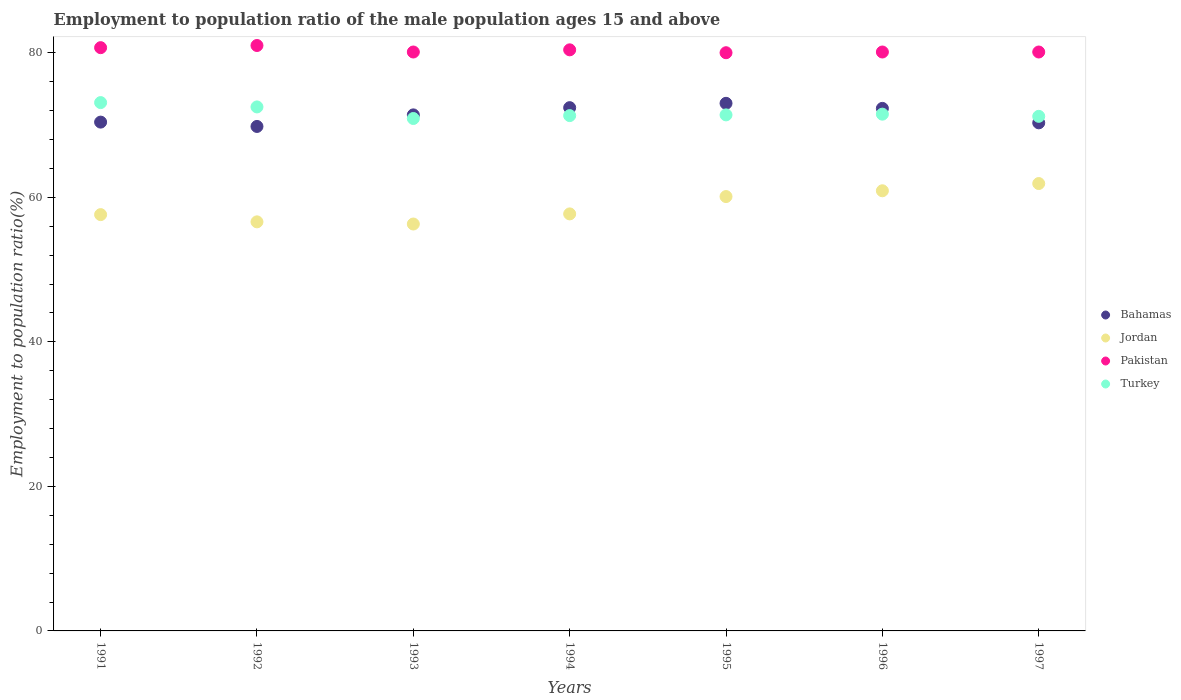What is the employment to population ratio in Bahamas in 1997?
Provide a succinct answer. 70.3. Across all years, what is the maximum employment to population ratio in Jordan?
Offer a terse response. 61.9. Across all years, what is the minimum employment to population ratio in Turkey?
Give a very brief answer. 70.9. In which year was the employment to population ratio in Pakistan maximum?
Keep it short and to the point. 1992. In which year was the employment to population ratio in Pakistan minimum?
Make the answer very short. 1995. What is the total employment to population ratio in Bahamas in the graph?
Offer a terse response. 499.6. What is the difference between the employment to population ratio in Pakistan in 1991 and the employment to population ratio in Turkey in 1995?
Provide a short and direct response. 9.3. What is the average employment to population ratio in Turkey per year?
Make the answer very short. 71.7. In the year 1992, what is the difference between the employment to population ratio in Pakistan and employment to population ratio in Bahamas?
Provide a succinct answer. 11.2. In how many years, is the employment to population ratio in Bahamas greater than 48 %?
Keep it short and to the point. 7. What is the ratio of the employment to population ratio in Pakistan in 1995 to that in 1997?
Your answer should be compact. 1. Is the employment to population ratio in Pakistan in 1993 less than that in 1996?
Offer a terse response. No. Is the difference between the employment to population ratio in Pakistan in 1995 and 1997 greater than the difference between the employment to population ratio in Bahamas in 1995 and 1997?
Your response must be concise. No. What is the difference between the highest and the second highest employment to population ratio in Bahamas?
Ensure brevity in your answer.  0.6. What is the difference between the highest and the lowest employment to population ratio in Jordan?
Make the answer very short. 5.6. Is it the case that in every year, the sum of the employment to population ratio in Jordan and employment to population ratio in Bahamas  is greater than the sum of employment to population ratio in Turkey and employment to population ratio in Pakistan?
Offer a terse response. No. Is it the case that in every year, the sum of the employment to population ratio in Turkey and employment to population ratio in Jordan  is greater than the employment to population ratio in Pakistan?
Your response must be concise. Yes. Is the employment to population ratio in Pakistan strictly less than the employment to population ratio in Bahamas over the years?
Make the answer very short. No. How many years are there in the graph?
Give a very brief answer. 7. Are the values on the major ticks of Y-axis written in scientific E-notation?
Your response must be concise. No. Does the graph contain grids?
Your answer should be compact. No. Where does the legend appear in the graph?
Offer a very short reply. Center right. How many legend labels are there?
Your response must be concise. 4. How are the legend labels stacked?
Ensure brevity in your answer.  Vertical. What is the title of the graph?
Offer a terse response. Employment to population ratio of the male population ages 15 and above. Does "Argentina" appear as one of the legend labels in the graph?
Your answer should be very brief. No. What is the label or title of the X-axis?
Provide a short and direct response. Years. What is the Employment to population ratio(%) of Bahamas in 1991?
Provide a succinct answer. 70.4. What is the Employment to population ratio(%) in Jordan in 1991?
Provide a short and direct response. 57.6. What is the Employment to population ratio(%) in Pakistan in 1991?
Keep it short and to the point. 80.7. What is the Employment to population ratio(%) of Turkey in 1991?
Provide a short and direct response. 73.1. What is the Employment to population ratio(%) of Bahamas in 1992?
Offer a terse response. 69.8. What is the Employment to population ratio(%) in Jordan in 1992?
Ensure brevity in your answer.  56.6. What is the Employment to population ratio(%) of Turkey in 1992?
Provide a succinct answer. 72.5. What is the Employment to population ratio(%) in Bahamas in 1993?
Keep it short and to the point. 71.4. What is the Employment to population ratio(%) of Jordan in 1993?
Your answer should be very brief. 56.3. What is the Employment to population ratio(%) in Pakistan in 1993?
Ensure brevity in your answer.  80.1. What is the Employment to population ratio(%) of Turkey in 1993?
Your answer should be compact. 70.9. What is the Employment to population ratio(%) in Bahamas in 1994?
Your response must be concise. 72.4. What is the Employment to population ratio(%) of Jordan in 1994?
Your answer should be compact. 57.7. What is the Employment to population ratio(%) of Pakistan in 1994?
Offer a very short reply. 80.4. What is the Employment to population ratio(%) of Turkey in 1994?
Offer a terse response. 71.3. What is the Employment to population ratio(%) in Jordan in 1995?
Keep it short and to the point. 60.1. What is the Employment to population ratio(%) of Turkey in 1995?
Offer a very short reply. 71.4. What is the Employment to population ratio(%) of Bahamas in 1996?
Keep it short and to the point. 72.3. What is the Employment to population ratio(%) in Jordan in 1996?
Offer a terse response. 60.9. What is the Employment to population ratio(%) in Pakistan in 1996?
Your response must be concise. 80.1. What is the Employment to population ratio(%) of Turkey in 1996?
Your answer should be very brief. 71.5. What is the Employment to population ratio(%) in Bahamas in 1997?
Offer a terse response. 70.3. What is the Employment to population ratio(%) of Jordan in 1997?
Make the answer very short. 61.9. What is the Employment to population ratio(%) of Pakistan in 1997?
Keep it short and to the point. 80.1. What is the Employment to population ratio(%) in Turkey in 1997?
Keep it short and to the point. 71.2. Across all years, what is the maximum Employment to population ratio(%) of Bahamas?
Offer a very short reply. 73. Across all years, what is the maximum Employment to population ratio(%) in Jordan?
Your answer should be compact. 61.9. Across all years, what is the maximum Employment to population ratio(%) of Pakistan?
Provide a short and direct response. 81. Across all years, what is the maximum Employment to population ratio(%) of Turkey?
Ensure brevity in your answer.  73.1. Across all years, what is the minimum Employment to population ratio(%) in Bahamas?
Ensure brevity in your answer.  69.8. Across all years, what is the minimum Employment to population ratio(%) of Jordan?
Ensure brevity in your answer.  56.3. Across all years, what is the minimum Employment to population ratio(%) of Pakistan?
Your answer should be very brief. 80. Across all years, what is the minimum Employment to population ratio(%) in Turkey?
Your answer should be very brief. 70.9. What is the total Employment to population ratio(%) of Bahamas in the graph?
Make the answer very short. 499.6. What is the total Employment to population ratio(%) of Jordan in the graph?
Provide a short and direct response. 411.1. What is the total Employment to population ratio(%) in Pakistan in the graph?
Offer a terse response. 562.4. What is the total Employment to population ratio(%) of Turkey in the graph?
Offer a very short reply. 501.9. What is the difference between the Employment to population ratio(%) in Bahamas in 1991 and that in 1992?
Make the answer very short. 0.6. What is the difference between the Employment to population ratio(%) of Turkey in 1991 and that in 1992?
Your answer should be compact. 0.6. What is the difference between the Employment to population ratio(%) of Bahamas in 1991 and that in 1993?
Ensure brevity in your answer.  -1. What is the difference between the Employment to population ratio(%) in Pakistan in 1991 and that in 1993?
Give a very brief answer. 0.6. What is the difference between the Employment to population ratio(%) in Bahamas in 1991 and that in 1994?
Provide a succinct answer. -2. What is the difference between the Employment to population ratio(%) in Pakistan in 1991 and that in 1994?
Make the answer very short. 0.3. What is the difference between the Employment to population ratio(%) in Turkey in 1991 and that in 1994?
Your answer should be very brief. 1.8. What is the difference between the Employment to population ratio(%) in Turkey in 1991 and that in 1995?
Ensure brevity in your answer.  1.7. What is the difference between the Employment to population ratio(%) in Jordan in 1991 and that in 1996?
Provide a succinct answer. -3.3. What is the difference between the Employment to population ratio(%) of Pakistan in 1991 and that in 1996?
Your answer should be very brief. 0.6. What is the difference between the Employment to population ratio(%) in Bahamas in 1991 and that in 1997?
Your answer should be very brief. 0.1. What is the difference between the Employment to population ratio(%) in Pakistan in 1991 and that in 1997?
Provide a succinct answer. 0.6. What is the difference between the Employment to population ratio(%) in Pakistan in 1992 and that in 1993?
Make the answer very short. 0.9. What is the difference between the Employment to population ratio(%) of Turkey in 1992 and that in 1994?
Keep it short and to the point. 1.2. What is the difference between the Employment to population ratio(%) of Bahamas in 1992 and that in 1995?
Make the answer very short. -3.2. What is the difference between the Employment to population ratio(%) in Pakistan in 1992 and that in 1995?
Ensure brevity in your answer.  1. What is the difference between the Employment to population ratio(%) of Turkey in 1992 and that in 1995?
Ensure brevity in your answer.  1.1. What is the difference between the Employment to population ratio(%) in Jordan in 1992 and that in 1996?
Your answer should be compact. -4.3. What is the difference between the Employment to population ratio(%) in Pakistan in 1992 and that in 1996?
Offer a very short reply. 0.9. What is the difference between the Employment to population ratio(%) of Turkey in 1992 and that in 1996?
Provide a short and direct response. 1. What is the difference between the Employment to population ratio(%) in Jordan in 1992 and that in 1997?
Provide a succinct answer. -5.3. What is the difference between the Employment to population ratio(%) in Pakistan in 1992 and that in 1997?
Make the answer very short. 0.9. What is the difference between the Employment to population ratio(%) in Turkey in 1992 and that in 1997?
Offer a terse response. 1.3. What is the difference between the Employment to population ratio(%) of Bahamas in 1993 and that in 1994?
Your response must be concise. -1. What is the difference between the Employment to population ratio(%) of Jordan in 1993 and that in 1994?
Keep it short and to the point. -1.4. What is the difference between the Employment to population ratio(%) of Bahamas in 1993 and that in 1995?
Provide a short and direct response. -1.6. What is the difference between the Employment to population ratio(%) of Jordan in 1993 and that in 1995?
Ensure brevity in your answer.  -3.8. What is the difference between the Employment to population ratio(%) of Pakistan in 1993 and that in 1995?
Provide a short and direct response. 0.1. What is the difference between the Employment to population ratio(%) in Bahamas in 1993 and that in 1996?
Your response must be concise. -0.9. What is the difference between the Employment to population ratio(%) in Jordan in 1993 and that in 1996?
Offer a very short reply. -4.6. What is the difference between the Employment to population ratio(%) of Turkey in 1993 and that in 1996?
Provide a succinct answer. -0.6. What is the difference between the Employment to population ratio(%) of Bahamas in 1993 and that in 1997?
Your answer should be very brief. 1.1. What is the difference between the Employment to population ratio(%) of Jordan in 1993 and that in 1997?
Offer a terse response. -5.6. What is the difference between the Employment to population ratio(%) of Pakistan in 1993 and that in 1997?
Your response must be concise. 0. What is the difference between the Employment to population ratio(%) in Turkey in 1993 and that in 1997?
Keep it short and to the point. -0.3. What is the difference between the Employment to population ratio(%) in Bahamas in 1994 and that in 1995?
Give a very brief answer. -0.6. What is the difference between the Employment to population ratio(%) in Pakistan in 1994 and that in 1995?
Offer a terse response. 0.4. What is the difference between the Employment to population ratio(%) of Bahamas in 1994 and that in 1996?
Your answer should be very brief. 0.1. What is the difference between the Employment to population ratio(%) of Pakistan in 1994 and that in 1996?
Keep it short and to the point. 0.3. What is the difference between the Employment to population ratio(%) of Bahamas in 1995 and that in 1996?
Provide a succinct answer. 0.7. What is the difference between the Employment to population ratio(%) in Turkey in 1995 and that in 1996?
Your answer should be compact. -0.1. What is the difference between the Employment to population ratio(%) in Jordan in 1995 and that in 1997?
Your response must be concise. -1.8. What is the difference between the Employment to population ratio(%) in Pakistan in 1995 and that in 1997?
Your answer should be compact. -0.1. What is the difference between the Employment to population ratio(%) of Pakistan in 1996 and that in 1997?
Your answer should be very brief. 0. What is the difference between the Employment to population ratio(%) in Turkey in 1996 and that in 1997?
Make the answer very short. 0.3. What is the difference between the Employment to population ratio(%) in Bahamas in 1991 and the Employment to population ratio(%) in Pakistan in 1992?
Keep it short and to the point. -10.6. What is the difference between the Employment to population ratio(%) in Jordan in 1991 and the Employment to population ratio(%) in Pakistan in 1992?
Your answer should be compact. -23.4. What is the difference between the Employment to population ratio(%) in Jordan in 1991 and the Employment to population ratio(%) in Turkey in 1992?
Offer a very short reply. -14.9. What is the difference between the Employment to population ratio(%) of Pakistan in 1991 and the Employment to population ratio(%) of Turkey in 1992?
Offer a very short reply. 8.2. What is the difference between the Employment to population ratio(%) in Bahamas in 1991 and the Employment to population ratio(%) in Jordan in 1993?
Offer a terse response. 14.1. What is the difference between the Employment to population ratio(%) of Bahamas in 1991 and the Employment to population ratio(%) of Pakistan in 1993?
Provide a succinct answer. -9.7. What is the difference between the Employment to population ratio(%) in Bahamas in 1991 and the Employment to population ratio(%) in Turkey in 1993?
Provide a short and direct response. -0.5. What is the difference between the Employment to population ratio(%) of Jordan in 1991 and the Employment to population ratio(%) of Pakistan in 1993?
Provide a short and direct response. -22.5. What is the difference between the Employment to population ratio(%) of Pakistan in 1991 and the Employment to population ratio(%) of Turkey in 1993?
Give a very brief answer. 9.8. What is the difference between the Employment to population ratio(%) in Bahamas in 1991 and the Employment to population ratio(%) in Jordan in 1994?
Ensure brevity in your answer.  12.7. What is the difference between the Employment to population ratio(%) of Jordan in 1991 and the Employment to population ratio(%) of Pakistan in 1994?
Ensure brevity in your answer.  -22.8. What is the difference between the Employment to population ratio(%) in Jordan in 1991 and the Employment to population ratio(%) in Turkey in 1994?
Offer a very short reply. -13.7. What is the difference between the Employment to population ratio(%) of Pakistan in 1991 and the Employment to population ratio(%) of Turkey in 1994?
Provide a short and direct response. 9.4. What is the difference between the Employment to population ratio(%) in Bahamas in 1991 and the Employment to population ratio(%) in Turkey in 1995?
Ensure brevity in your answer.  -1. What is the difference between the Employment to population ratio(%) in Jordan in 1991 and the Employment to population ratio(%) in Pakistan in 1995?
Give a very brief answer. -22.4. What is the difference between the Employment to population ratio(%) in Jordan in 1991 and the Employment to population ratio(%) in Turkey in 1995?
Your answer should be compact. -13.8. What is the difference between the Employment to population ratio(%) of Pakistan in 1991 and the Employment to population ratio(%) of Turkey in 1995?
Your answer should be compact. 9.3. What is the difference between the Employment to population ratio(%) in Bahamas in 1991 and the Employment to population ratio(%) in Jordan in 1996?
Provide a short and direct response. 9.5. What is the difference between the Employment to population ratio(%) of Bahamas in 1991 and the Employment to population ratio(%) of Pakistan in 1996?
Give a very brief answer. -9.7. What is the difference between the Employment to population ratio(%) of Bahamas in 1991 and the Employment to population ratio(%) of Turkey in 1996?
Offer a terse response. -1.1. What is the difference between the Employment to population ratio(%) of Jordan in 1991 and the Employment to population ratio(%) of Pakistan in 1996?
Keep it short and to the point. -22.5. What is the difference between the Employment to population ratio(%) in Jordan in 1991 and the Employment to population ratio(%) in Turkey in 1996?
Give a very brief answer. -13.9. What is the difference between the Employment to population ratio(%) in Pakistan in 1991 and the Employment to population ratio(%) in Turkey in 1996?
Your response must be concise. 9.2. What is the difference between the Employment to population ratio(%) of Bahamas in 1991 and the Employment to population ratio(%) of Pakistan in 1997?
Make the answer very short. -9.7. What is the difference between the Employment to population ratio(%) of Jordan in 1991 and the Employment to population ratio(%) of Pakistan in 1997?
Provide a short and direct response. -22.5. What is the difference between the Employment to population ratio(%) of Pakistan in 1991 and the Employment to population ratio(%) of Turkey in 1997?
Provide a short and direct response. 9.5. What is the difference between the Employment to population ratio(%) of Bahamas in 1992 and the Employment to population ratio(%) of Jordan in 1993?
Give a very brief answer. 13.5. What is the difference between the Employment to population ratio(%) of Bahamas in 1992 and the Employment to population ratio(%) of Turkey in 1993?
Offer a terse response. -1.1. What is the difference between the Employment to population ratio(%) of Jordan in 1992 and the Employment to population ratio(%) of Pakistan in 1993?
Provide a short and direct response. -23.5. What is the difference between the Employment to population ratio(%) in Jordan in 1992 and the Employment to population ratio(%) in Turkey in 1993?
Provide a short and direct response. -14.3. What is the difference between the Employment to population ratio(%) in Bahamas in 1992 and the Employment to population ratio(%) in Jordan in 1994?
Make the answer very short. 12.1. What is the difference between the Employment to population ratio(%) of Bahamas in 1992 and the Employment to population ratio(%) of Pakistan in 1994?
Your answer should be compact. -10.6. What is the difference between the Employment to population ratio(%) of Jordan in 1992 and the Employment to population ratio(%) of Pakistan in 1994?
Ensure brevity in your answer.  -23.8. What is the difference between the Employment to population ratio(%) of Jordan in 1992 and the Employment to population ratio(%) of Turkey in 1994?
Your answer should be very brief. -14.7. What is the difference between the Employment to population ratio(%) in Pakistan in 1992 and the Employment to population ratio(%) in Turkey in 1994?
Offer a terse response. 9.7. What is the difference between the Employment to population ratio(%) of Bahamas in 1992 and the Employment to population ratio(%) of Jordan in 1995?
Your answer should be compact. 9.7. What is the difference between the Employment to population ratio(%) in Bahamas in 1992 and the Employment to population ratio(%) in Turkey in 1995?
Offer a very short reply. -1.6. What is the difference between the Employment to population ratio(%) in Jordan in 1992 and the Employment to population ratio(%) in Pakistan in 1995?
Your answer should be very brief. -23.4. What is the difference between the Employment to population ratio(%) in Jordan in 1992 and the Employment to population ratio(%) in Turkey in 1995?
Offer a terse response. -14.8. What is the difference between the Employment to population ratio(%) in Pakistan in 1992 and the Employment to population ratio(%) in Turkey in 1995?
Give a very brief answer. 9.6. What is the difference between the Employment to population ratio(%) in Bahamas in 1992 and the Employment to population ratio(%) in Jordan in 1996?
Ensure brevity in your answer.  8.9. What is the difference between the Employment to population ratio(%) of Bahamas in 1992 and the Employment to population ratio(%) of Pakistan in 1996?
Your response must be concise. -10.3. What is the difference between the Employment to population ratio(%) of Jordan in 1992 and the Employment to population ratio(%) of Pakistan in 1996?
Ensure brevity in your answer.  -23.5. What is the difference between the Employment to population ratio(%) in Jordan in 1992 and the Employment to population ratio(%) in Turkey in 1996?
Keep it short and to the point. -14.9. What is the difference between the Employment to population ratio(%) of Bahamas in 1992 and the Employment to population ratio(%) of Jordan in 1997?
Ensure brevity in your answer.  7.9. What is the difference between the Employment to population ratio(%) of Bahamas in 1992 and the Employment to population ratio(%) of Pakistan in 1997?
Offer a very short reply. -10.3. What is the difference between the Employment to population ratio(%) of Bahamas in 1992 and the Employment to population ratio(%) of Turkey in 1997?
Provide a succinct answer. -1.4. What is the difference between the Employment to population ratio(%) in Jordan in 1992 and the Employment to population ratio(%) in Pakistan in 1997?
Provide a succinct answer. -23.5. What is the difference between the Employment to population ratio(%) of Jordan in 1992 and the Employment to population ratio(%) of Turkey in 1997?
Ensure brevity in your answer.  -14.6. What is the difference between the Employment to population ratio(%) of Bahamas in 1993 and the Employment to population ratio(%) of Jordan in 1994?
Your answer should be very brief. 13.7. What is the difference between the Employment to population ratio(%) in Bahamas in 1993 and the Employment to population ratio(%) in Turkey in 1994?
Ensure brevity in your answer.  0.1. What is the difference between the Employment to population ratio(%) of Jordan in 1993 and the Employment to population ratio(%) of Pakistan in 1994?
Offer a terse response. -24.1. What is the difference between the Employment to population ratio(%) of Jordan in 1993 and the Employment to population ratio(%) of Turkey in 1994?
Make the answer very short. -15. What is the difference between the Employment to population ratio(%) of Pakistan in 1993 and the Employment to population ratio(%) of Turkey in 1994?
Offer a very short reply. 8.8. What is the difference between the Employment to population ratio(%) in Bahamas in 1993 and the Employment to population ratio(%) in Turkey in 1995?
Ensure brevity in your answer.  0. What is the difference between the Employment to population ratio(%) of Jordan in 1993 and the Employment to population ratio(%) of Pakistan in 1995?
Provide a succinct answer. -23.7. What is the difference between the Employment to population ratio(%) in Jordan in 1993 and the Employment to population ratio(%) in Turkey in 1995?
Offer a terse response. -15.1. What is the difference between the Employment to population ratio(%) in Pakistan in 1993 and the Employment to population ratio(%) in Turkey in 1995?
Your answer should be very brief. 8.7. What is the difference between the Employment to population ratio(%) in Bahamas in 1993 and the Employment to population ratio(%) in Pakistan in 1996?
Provide a succinct answer. -8.7. What is the difference between the Employment to population ratio(%) of Jordan in 1993 and the Employment to population ratio(%) of Pakistan in 1996?
Provide a succinct answer. -23.8. What is the difference between the Employment to population ratio(%) in Jordan in 1993 and the Employment to population ratio(%) in Turkey in 1996?
Keep it short and to the point. -15.2. What is the difference between the Employment to population ratio(%) in Pakistan in 1993 and the Employment to population ratio(%) in Turkey in 1996?
Give a very brief answer. 8.6. What is the difference between the Employment to population ratio(%) of Bahamas in 1993 and the Employment to population ratio(%) of Turkey in 1997?
Keep it short and to the point. 0.2. What is the difference between the Employment to population ratio(%) in Jordan in 1993 and the Employment to population ratio(%) in Pakistan in 1997?
Your answer should be compact. -23.8. What is the difference between the Employment to population ratio(%) in Jordan in 1993 and the Employment to population ratio(%) in Turkey in 1997?
Ensure brevity in your answer.  -14.9. What is the difference between the Employment to population ratio(%) of Jordan in 1994 and the Employment to population ratio(%) of Pakistan in 1995?
Keep it short and to the point. -22.3. What is the difference between the Employment to population ratio(%) of Jordan in 1994 and the Employment to population ratio(%) of Turkey in 1995?
Your response must be concise. -13.7. What is the difference between the Employment to population ratio(%) of Pakistan in 1994 and the Employment to population ratio(%) of Turkey in 1995?
Your answer should be very brief. 9. What is the difference between the Employment to population ratio(%) in Bahamas in 1994 and the Employment to population ratio(%) in Turkey in 1996?
Keep it short and to the point. 0.9. What is the difference between the Employment to population ratio(%) of Jordan in 1994 and the Employment to population ratio(%) of Pakistan in 1996?
Your answer should be compact. -22.4. What is the difference between the Employment to population ratio(%) of Jordan in 1994 and the Employment to population ratio(%) of Pakistan in 1997?
Ensure brevity in your answer.  -22.4. What is the difference between the Employment to population ratio(%) in Jordan in 1994 and the Employment to population ratio(%) in Turkey in 1997?
Provide a short and direct response. -13.5. What is the difference between the Employment to population ratio(%) of Pakistan in 1994 and the Employment to population ratio(%) of Turkey in 1997?
Make the answer very short. 9.2. What is the difference between the Employment to population ratio(%) in Bahamas in 1995 and the Employment to population ratio(%) in Turkey in 1996?
Provide a short and direct response. 1.5. What is the difference between the Employment to population ratio(%) in Pakistan in 1995 and the Employment to population ratio(%) in Turkey in 1996?
Provide a short and direct response. 8.5. What is the difference between the Employment to population ratio(%) of Bahamas in 1995 and the Employment to population ratio(%) of Turkey in 1997?
Your answer should be compact. 1.8. What is the difference between the Employment to population ratio(%) in Jordan in 1995 and the Employment to population ratio(%) in Turkey in 1997?
Your answer should be very brief. -11.1. What is the difference between the Employment to population ratio(%) of Pakistan in 1995 and the Employment to population ratio(%) of Turkey in 1997?
Offer a terse response. 8.8. What is the difference between the Employment to population ratio(%) of Bahamas in 1996 and the Employment to population ratio(%) of Pakistan in 1997?
Ensure brevity in your answer.  -7.8. What is the difference between the Employment to population ratio(%) in Bahamas in 1996 and the Employment to population ratio(%) in Turkey in 1997?
Make the answer very short. 1.1. What is the difference between the Employment to population ratio(%) in Jordan in 1996 and the Employment to population ratio(%) in Pakistan in 1997?
Your answer should be compact. -19.2. What is the difference between the Employment to population ratio(%) of Jordan in 1996 and the Employment to population ratio(%) of Turkey in 1997?
Give a very brief answer. -10.3. What is the difference between the Employment to population ratio(%) of Pakistan in 1996 and the Employment to population ratio(%) of Turkey in 1997?
Your response must be concise. 8.9. What is the average Employment to population ratio(%) of Bahamas per year?
Your answer should be very brief. 71.37. What is the average Employment to population ratio(%) of Jordan per year?
Provide a short and direct response. 58.73. What is the average Employment to population ratio(%) in Pakistan per year?
Your answer should be very brief. 80.34. What is the average Employment to population ratio(%) in Turkey per year?
Give a very brief answer. 71.7. In the year 1991, what is the difference between the Employment to population ratio(%) in Bahamas and Employment to population ratio(%) in Jordan?
Offer a terse response. 12.8. In the year 1991, what is the difference between the Employment to population ratio(%) in Bahamas and Employment to population ratio(%) in Pakistan?
Provide a short and direct response. -10.3. In the year 1991, what is the difference between the Employment to population ratio(%) in Jordan and Employment to population ratio(%) in Pakistan?
Your answer should be very brief. -23.1. In the year 1991, what is the difference between the Employment to population ratio(%) in Jordan and Employment to population ratio(%) in Turkey?
Your response must be concise. -15.5. In the year 1991, what is the difference between the Employment to population ratio(%) in Pakistan and Employment to population ratio(%) in Turkey?
Provide a succinct answer. 7.6. In the year 1992, what is the difference between the Employment to population ratio(%) of Bahamas and Employment to population ratio(%) of Pakistan?
Make the answer very short. -11.2. In the year 1992, what is the difference between the Employment to population ratio(%) in Jordan and Employment to population ratio(%) in Pakistan?
Provide a short and direct response. -24.4. In the year 1992, what is the difference between the Employment to population ratio(%) of Jordan and Employment to population ratio(%) of Turkey?
Offer a terse response. -15.9. In the year 1992, what is the difference between the Employment to population ratio(%) of Pakistan and Employment to population ratio(%) of Turkey?
Ensure brevity in your answer.  8.5. In the year 1993, what is the difference between the Employment to population ratio(%) in Bahamas and Employment to population ratio(%) in Jordan?
Ensure brevity in your answer.  15.1. In the year 1993, what is the difference between the Employment to population ratio(%) in Bahamas and Employment to population ratio(%) in Turkey?
Offer a very short reply. 0.5. In the year 1993, what is the difference between the Employment to population ratio(%) in Jordan and Employment to population ratio(%) in Pakistan?
Your answer should be very brief. -23.8. In the year 1993, what is the difference between the Employment to population ratio(%) in Jordan and Employment to population ratio(%) in Turkey?
Your answer should be compact. -14.6. In the year 1993, what is the difference between the Employment to population ratio(%) in Pakistan and Employment to population ratio(%) in Turkey?
Your answer should be very brief. 9.2. In the year 1994, what is the difference between the Employment to population ratio(%) of Bahamas and Employment to population ratio(%) of Jordan?
Your answer should be compact. 14.7. In the year 1994, what is the difference between the Employment to population ratio(%) of Bahamas and Employment to population ratio(%) of Pakistan?
Give a very brief answer. -8. In the year 1994, what is the difference between the Employment to population ratio(%) of Bahamas and Employment to population ratio(%) of Turkey?
Keep it short and to the point. 1.1. In the year 1994, what is the difference between the Employment to population ratio(%) of Jordan and Employment to population ratio(%) of Pakistan?
Make the answer very short. -22.7. In the year 1994, what is the difference between the Employment to population ratio(%) in Jordan and Employment to population ratio(%) in Turkey?
Offer a very short reply. -13.6. In the year 1995, what is the difference between the Employment to population ratio(%) of Bahamas and Employment to population ratio(%) of Jordan?
Offer a terse response. 12.9. In the year 1995, what is the difference between the Employment to population ratio(%) of Bahamas and Employment to population ratio(%) of Pakistan?
Your answer should be very brief. -7. In the year 1995, what is the difference between the Employment to population ratio(%) in Jordan and Employment to population ratio(%) in Pakistan?
Your answer should be compact. -19.9. In the year 1995, what is the difference between the Employment to population ratio(%) of Pakistan and Employment to population ratio(%) of Turkey?
Offer a very short reply. 8.6. In the year 1996, what is the difference between the Employment to population ratio(%) of Bahamas and Employment to population ratio(%) of Jordan?
Offer a terse response. 11.4. In the year 1996, what is the difference between the Employment to population ratio(%) in Jordan and Employment to population ratio(%) in Pakistan?
Your answer should be compact. -19.2. In the year 1996, what is the difference between the Employment to population ratio(%) in Jordan and Employment to population ratio(%) in Turkey?
Your answer should be very brief. -10.6. In the year 1997, what is the difference between the Employment to population ratio(%) in Bahamas and Employment to population ratio(%) in Jordan?
Provide a succinct answer. 8.4. In the year 1997, what is the difference between the Employment to population ratio(%) in Bahamas and Employment to population ratio(%) in Pakistan?
Your answer should be compact. -9.8. In the year 1997, what is the difference between the Employment to population ratio(%) in Bahamas and Employment to population ratio(%) in Turkey?
Your answer should be very brief. -0.9. In the year 1997, what is the difference between the Employment to population ratio(%) of Jordan and Employment to population ratio(%) of Pakistan?
Your answer should be compact. -18.2. What is the ratio of the Employment to population ratio(%) of Bahamas in 1991 to that in 1992?
Your response must be concise. 1.01. What is the ratio of the Employment to population ratio(%) in Jordan in 1991 to that in 1992?
Give a very brief answer. 1.02. What is the ratio of the Employment to population ratio(%) in Pakistan in 1991 to that in 1992?
Provide a short and direct response. 1. What is the ratio of the Employment to population ratio(%) in Turkey in 1991 to that in 1992?
Keep it short and to the point. 1.01. What is the ratio of the Employment to population ratio(%) of Jordan in 1991 to that in 1993?
Make the answer very short. 1.02. What is the ratio of the Employment to population ratio(%) in Pakistan in 1991 to that in 1993?
Provide a short and direct response. 1.01. What is the ratio of the Employment to population ratio(%) of Turkey in 1991 to that in 1993?
Provide a succinct answer. 1.03. What is the ratio of the Employment to population ratio(%) of Bahamas in 1991 to that in 1994?
Provide a short and direct response. 0.97. What is the ratio of the Employment to population ratio(%) in Turkey in 1991 to that in 1994?
Keep it short and to the point. 1.03. What is the ratio of the Employment to population ratio(%) of Bahamas in 1991 to that in 1995?
Keep it short and to the point. 0.96. What is the ratio of the Employment to population ratio(%) of Jordan in 1991 to that in 1995?
Your answer should be compact. 0.96. What is the ratio of the Employment to population ratio(%) of Pakistan in 1991 to that in 1995?
Your answer should be compact. 1.01. What is the ratio of the Employment to population ratio(%) in Turkey in 1991 to that in 1995?
Offer a very short reply. 1.02. What is the ratio of the Employment to population ratio(%) in Bahamas in 1991 to that in 1996?
Offer a terse response. 0.97. What is the ratio of the Employment to population ratio(%) of Jordan in 1991 to that in 1996?
Offer a very short reply. 0.95. What is the ratio of the Employment to population ratio(%) in Pakistan in 1991 to that in 1996?
Provide a short and direct response. 1.01. What is the ratio of the Employment to population ratio(%) in Turkey in 1991 to that in 1996?
Offer a terse response. 1.02. What is the ratio of the Employment to population ratio(%) in Bahamas in 1991 to that in 1997?
Offer a terse response. 1. What is the ratio of the Employment to population ratio(%) in Jordan in 1991 to that in 1997?
Make the answer very short. 0.93. What is the ratio of the Employment to population ratio(%) in Pakistan in 1991 to that in 1997?
Your answer should be compact. 1.01. What is the ratio of the Employment to population ratio(%) in Turkey in 1991 to that in 1997?
Offer a terse response. 1.03. What is the ratio of the Employment to population ratio(%) in Bahamas in 1992 to that in 1993?
Provide a short and direct response. 0.98. What is the ratio of the Employment to population ratio(%) of Pakistan in 1992 to that in 1993?
Keep it short and to the point. 1.01. What is the ratio of the Employment to population ratio(%) in Turkey in 1992 to that in 1993?
Your response must be concise. 1.02. What is the ratio of the Employment to population ratio(%) in Bahamas in 1992 to that in 1994?
Your answer should be compact. 0.96. What is the ratio of the Employment to population ratio(%) of Jordan in 1992 to that in 1994?
Give a very brief answer. 0.98. What is the ratio of the Employment to population ratio(%) in Pakistan in 1992 to that in 1994?
Offer a very short reply. 1.01. What is the ratio of the Employment to population ratio(%) in Turkey in 1992 to that in 1994?
Your answer should be compact. 1.02. What is the ratio of the Employment to population ratio(%) in Bahamas in 1992 to that in 1995?
Give a very brief answer. 0.96. What is the ratio of the Employment to population ratio(%) of Jordan in 1992 to that in 1995?
Your response must be concise. 0.94. What is the ratio of the Employment to population ratio(%) in Pakistan in 1992 to that in 1995?
Provide a short and direct response. 1.01. What is the ratio of the Employment to population ratio(%) of Turkey in 1992 to that in 1995?
Keep it short and to the point. 1.02. What is the ratio of the Employment to population ratio(%) of Bahamas in 1992 to that in 1996?
Make the answer very short. 0.97. What is the ratio of the Employment to population ratio(%) of Jordan in 1992 to that in 1996?
Make the answer very short. 0.93. What is the ratio of the Employment to population ratio(%) in Pakistan in 1992 to that in 1996?
Your answer should be compact. 1.01. What is the ratio of the Employment to population ratio(%) in Bahamas in 1992 to that in 1997?
Keep it short and to the point. 0.99. What is the ratio of the Employment to population ratio(%) in Jordan in 1992 to that in 1997?
Provide a succinct answer. 0.91. What is the ratio of the Employment to population ratio(%) in Pakistan in 1992 to that in 1997?
Provide a short and direct response. 1.01. What is the ratio of the Employment to population ratio(%) of Turkey in 1992 to that in 1997?
Your response must be concise. 1.02. What is the ratio of the Employment to population ratio(%) in Bahamas in 1993 to that in 1994?
Give a very brief answer. 0.99. What is the ratio of the Employment to population ratio(%) of Jordan in 1993 to that in 1994?
Give a very brief answer. 0.98. What is the ratio of the Employment to population ratio(%) of Turkey in 1993 to that in 1994?
Provide a short and direct response. 0.99. What is the ratio of the Employment to population ratio(%) in Bahamas in 1993 to that in 1995?
Provide a short and direct response. 0.98. What is the ratio of the Employment to population ratio(%) of Jordan in 1993 to that in 1995?
Give a very brief answer. 0.94. What is the ratio of the Employment to population ratio(%) in Pakistan in 1993 to that in 1995?
Offer a terse response. 1. What is the ratio of the Employment to population ratio(%) in Bahamas in 1993 to that in 1996?
Your answer should be very brief. 0.99. What is the ratio of the Employment to population ratio(%) in Jordan in 1993 to that in 1996?
Keep it short and to the point. 0.92. What is the ratio of the Employment to population ratio(%) in Bahamas in 1993 to that in 1997?
Provide a short and direct response. 1.02. What is the ratio of the Employment to population ratio(%) in Jordan in 1993 to that in 1997?
Give a very brief answer. 0.91. What is the ratio of the Employment to population ratio(%) of Pakistan in 1993 to that in 1997?
Offer a terse response. 1. What is the ratio of the Employment to population ratio(%) in Bahamas in 1994 to that in 1995?
Offer a terse response. 0.99. What is the ratio of the Employment to population ratio(%) in Jordan in 1994 to that in 1995?
Provide a succinct answer. 0.96. What is the ratio of the Employment to population ratio(%) of Bahamas in 1994 to that in 1996?
Make the answer very short. 1. What is the ratio of the Employment to population ratio(%) of Jordan in 1994 to that in 1996?
Keep it short and to the point. 0.95. What is the ratio of the Employment to population ratio(%) in Pakistan in 1994 to that in 1996?
Your response must be concise. 1. What is the ratio of the Employment to population ratio(%) in Turkey in 1994 to that in 1996?
Your answer should be very brief. 1. What is the ratio of the Employment to population ratio(%) of Bahamas in 1994 to that in 1997?
Give a very brief answer. 1.03. What is the ratio of the Employment to population ratio(%) in Jordan in 1994 to that in 1997?
Give a very brief answer. 0.93. What is the ratio of the Employment to population ratio(%) of Pakistan in 1994 to that in 1997?
Your answer should be compact. 1. What is the ratio of the Employment to population ratio(%) of Bahamas in 1995 to that in 1996?
Your answer should be compact. 1.01. What is the ratio of the Employment to population ratio(%) of Jordan in 1995 to that in 1996?
Provide a short and direct response. 0.99. What is the ratio of the Employment to population ratio(%) of Turkey in 1995 to that in 1996?
Offer a terse response. 1. What is the ratio of the Employment to population ratio(%) in Bahamas in 1995 to that in 1997?
Your answer should be very brief. 1.04. What is the ratio of the Employment to population ratio(%) of Jordan in 1995 to that in 1997?
Provide a short and direct response. 0.97. What is the ratio of the Employment to population ratio(%) of Turkey in 1995 to that in 1997?
Give a very brief answer. 1. What is the ratio of the Employment to population ratio(%) of Bahamas in 1996 to that in 1997?
Offer a terse response. 1.03. What is the ratio of the Employment to population ratio(%) of Jordan in 1996 to that in 1997?
Make the answer very short. 0.98. What is the ratio of the Employment to population ratio(%) in Pakistan in 1996 to that in 1997?
Your answer should be compact. 1. What is the ratio of the Employment to population ratio(%) in Turkey in 1996 to that in 1997?
Your answer should be very brief. 1. What is the difference between the highest and the second highest Employment to population ratio(%) of Pakistan?
Keep it short and to the point. 0.3. What is the difference between the highest and the second highest Employment to population ratio(%) of Turkey?
Make the answer very short. 0.6. What is the difference between the highest and the lowest Employment to population ratio(%) in Bahamas?
Give a very brief answer. 3.2. What is the difference between the highest and the lowest Employment to population ratio(%) in Jordan?
Provide a succinct answer. 5.6. What is the difference between the highest and the lowest Employment to population ratio(%) of Pakistan?
Give a very brief answer. 1. What is the difference between the highest and the lowest Employment to population ratio(%) in Turkey?
Your response must be concise. 2.2. 